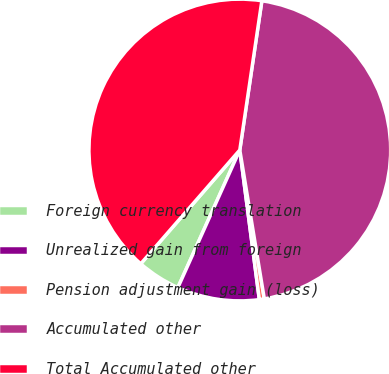Convert chart to OTSL. <chart><loc_0><loc_0><loc_500><loc_500><pie_chart><fcel>Foreign currency translation<fcel>Unrealized gain from foreign<fcel>Pension adjustment gain (loss)<fcel>Accumulated other<fcel>Total Accumulated other<nl><fcel>4.67%<fcel>8.8%<fcel>0.53%<fcel>45.07%<fcel>40.94%<nl></chart> 